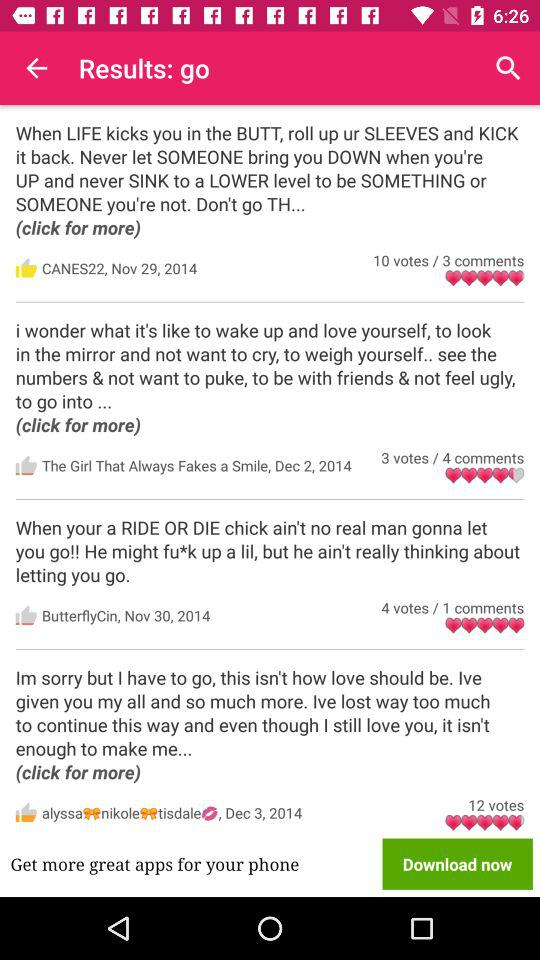How many votes did ButterflyCin get? ButterflyCin got 4 votes. 